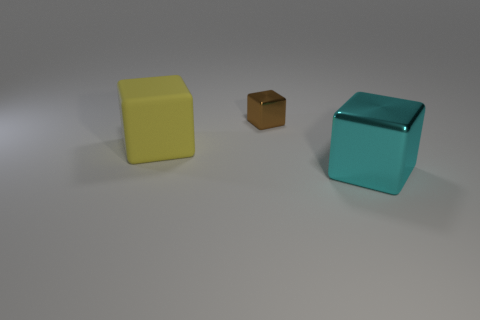What number of other objects are the same material as the big yellow cube?
Your response must be concise. 0. Is the number of cyan cubes left of the cyan metallic cube the same as the number of tiny green metallic cylinders?
Ensure brevity in your answer.  Yes. Do the cyan cube and the shiny block that is to the left of the cyan shiny block have the same size?
Make the answer very short. No. What is the shape of the yellow thing that is in front of the brown object?
Your answer should be very brief. Cube. Are any red balls visible?
Offer a terse response. No. There is a shiny object on the left side of the cyan block; is it the same size as the shiny block that is in front of the rubber object?
Ensure brevity in your answer.  No. There is a thing that is both in front of the tiny shiny object and behind the large cyan metal thing; what material is it?
Give a very brief answer. Rubber. How many tiny things are in front of the large cyan metallic block?
Provide a succinct answer. 0. Are there any other things that are the same size as the brown metallic object?
Ensure brevity in your answer.  No. There is another thing that is the same material as the cyan object; what is its color?
Give a very brief answer. Brown. 